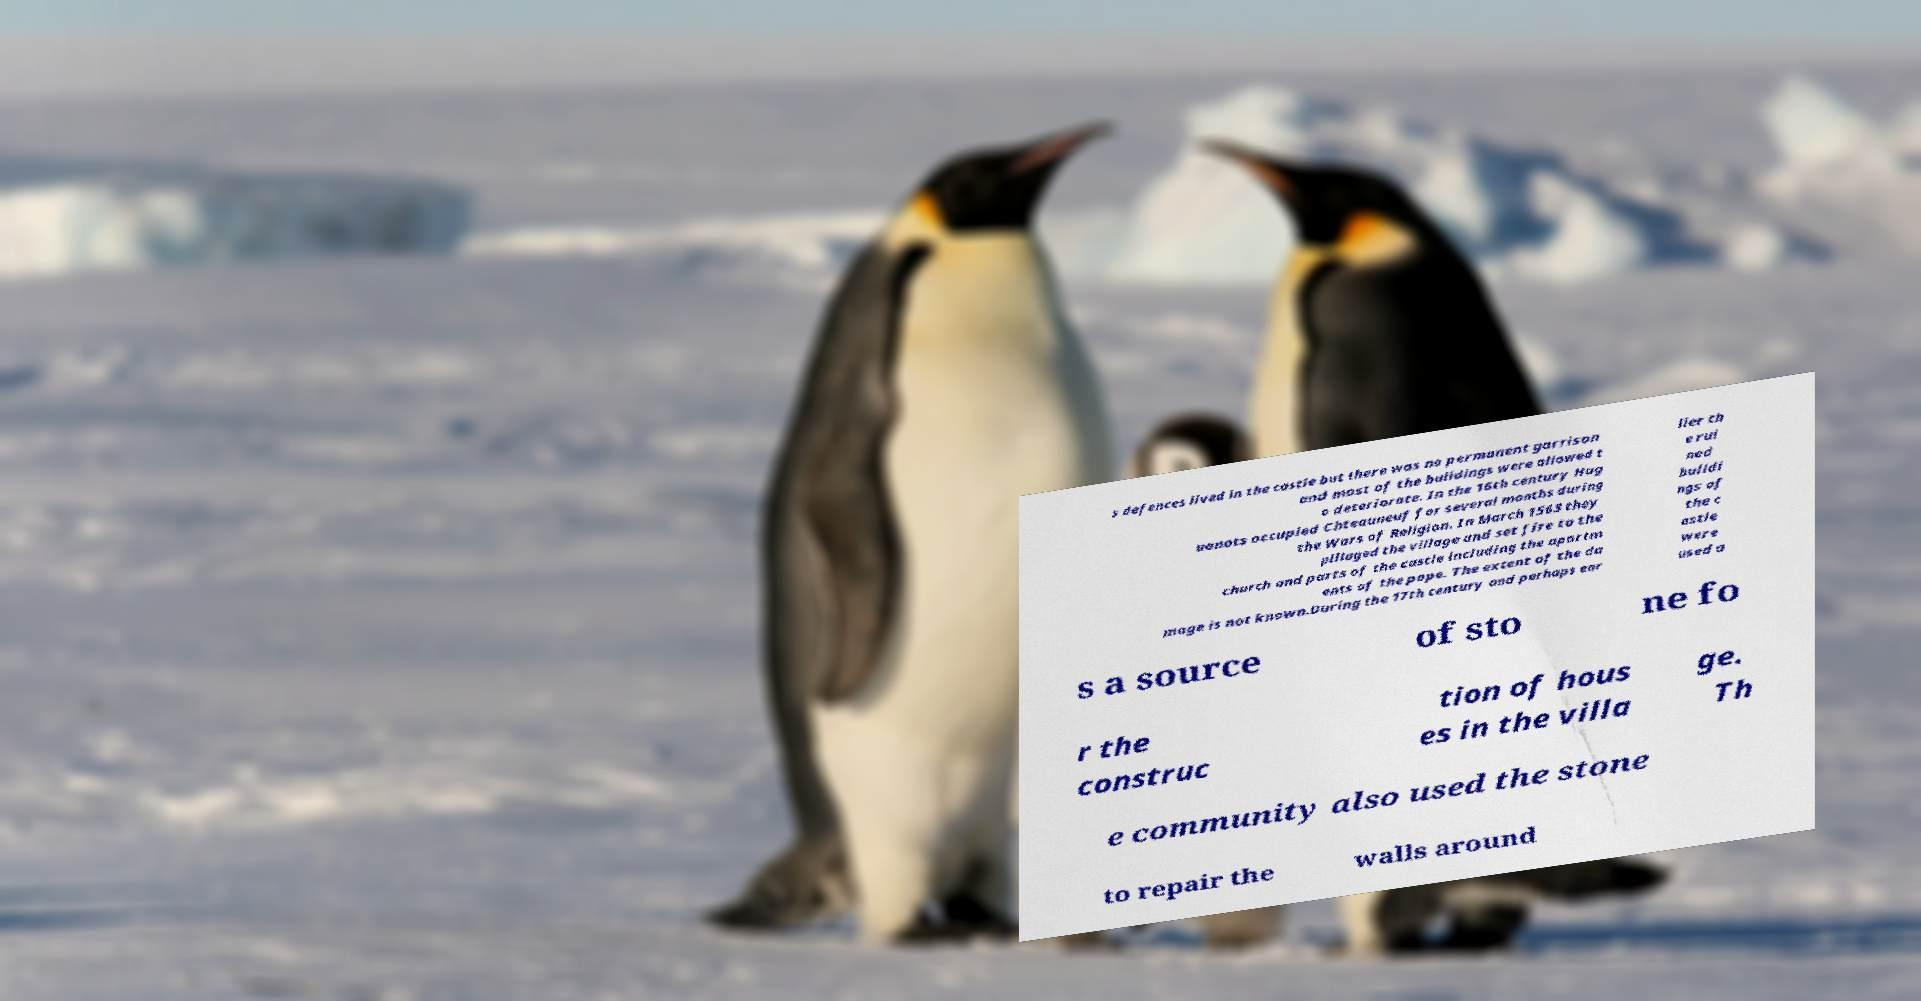For documentation purposes, I need the text within this image transcribed. Could you provide that? s defences lived in the castle but there was no permanent garrison and most of the buildings were allowed t o deteriorate. In the 16th century Hug uenots occupied Chteauneuf for several months during the Wars of Religion. In March 1563 they pillaged the village and set fire to the church and parts of the castle including the apartm ents of the pope. The extent of the da mage is not known.During the 17th century and perhaps ear lier th e rui ned buildi ngs of the c astle were used a s a source of sto ne fo r the construc tion of hous es in the villa ge. Th e community also used the stone to repair the walls around 